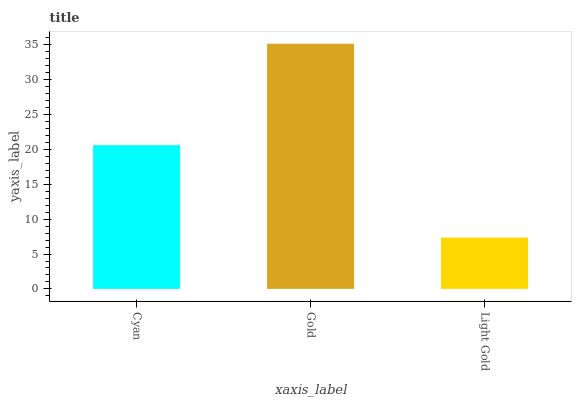Is Gold the minimum?
Answer yes or no. No. Is Light Gold the maximum?
Answer yes or no. No. Is Gold greater than Light Gold?
Answer yes or no. Yes. Is Light Gold less than Gold?
Answer yes or no. Yes. Is Light Gold greater than Gold?
Answer yes or no. No. Is Gold less than Light Gold?
Answer yes or no. No. Is Cyan the high median?
Answer yes or no. Yes. Is Cyan the low median?
Answer yes or no. Yes. Is Light Gold the high median?
Answer yes or no. No. Is Gold the low median?
Answer yes or no. No. 